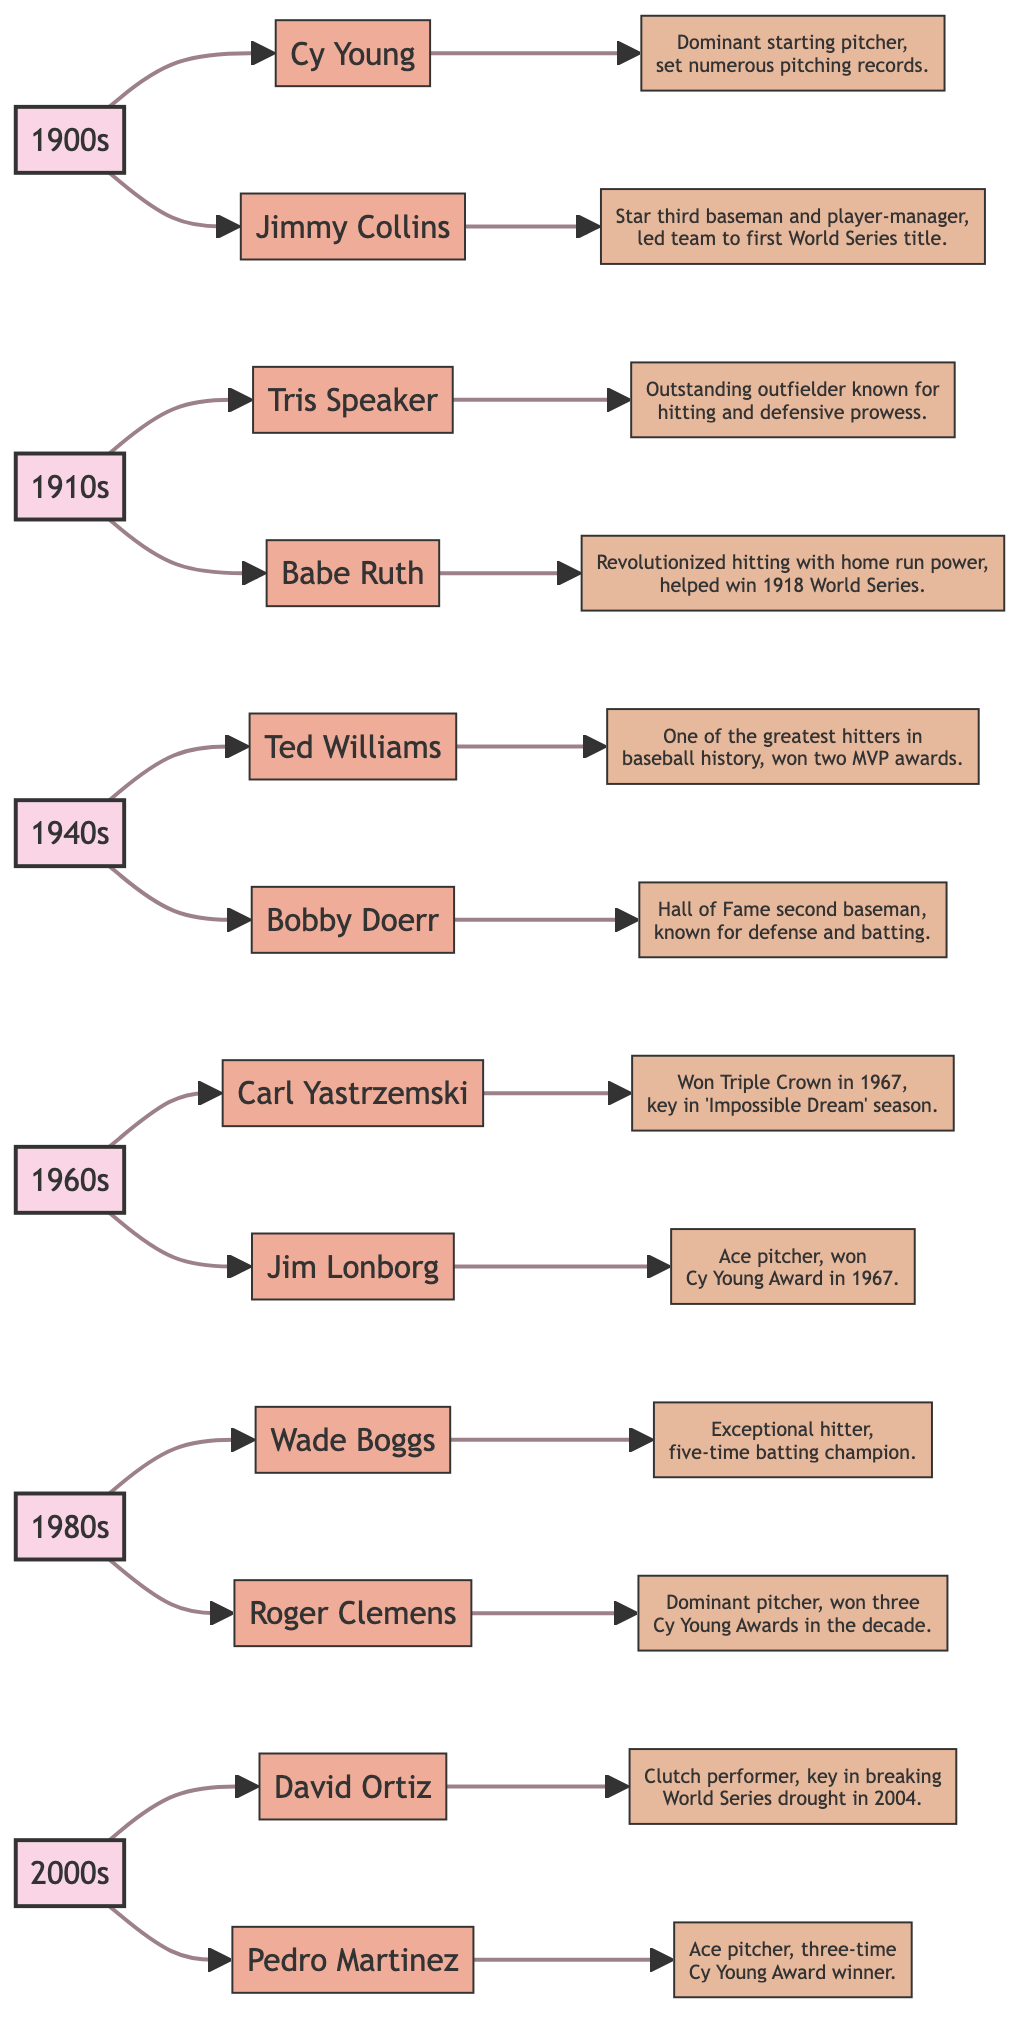What were the key contributions of Cy Young? From the diagram, Cy Young is connected to a contribution stating he was a "Dominant starting pitcher, set numerous pitching records." From the flowchart, we see the contribution directly related to his node.
Answer: Dominant starting pitcher, set numerous pitching records Which player from the 1910s helped win the World Series? The diagram shows that Babe Ruth, linked from the 1910s node, is stated to have "Revolutionized hitting with home run power, helping the team win the 1918 World Series." This indicates he played a significant role in that victory.
Answer: Babe Ruth How many Cy Young Awards did Roger Clemens win during the 1980s? According to the diagram, Roger Clemens is connected to the contribution stating he "won three Cy Young Awards during the decade." By counting this information directly from his node, we determine the result.
Answer: three Which player was noted for winning the Triple Crown in 1967? The diagram clearly shows Carl Yastrzemski being linked to the description stating he "Won the Triple Crown in 1967, key player in the 'Impossible Dream' season." Therefore, he is the one recognized for this achievement.
Answer: Carl Yastrzemski Name a player from the 1940s who won two MVP awards. According to the diagram, Ted Williams is linked to a contribution saying he is "One of the greatest hitters in baseball history, won two MVP awards." This indicates his achievement of winning MVPs in that decade.
Answer: Ted Williams Which decade includes the players David Ortiz and Pedro Martinez? The diagram shows the players David Ortiz and Pedro Martinez connected to the 2000s node. Therefore, we can directly refer back to this node to clarify the decade associated with these players.
Answer: 2000s Who is recognized as a Hall of Fame second baseman from the 1940s? The diagram presents Bobby Doerr under the 1940s node, linking him to the contribution stating he is a "Hall of Fame second baseman." Therefore, he is the recognized player for this accolade.
Answer: Bobby Doerr What pattern of contribution is shared by both players from the 1980s? Looking at the flowchart, both Wade Boggs and Roger Clemens are linked to contributions emphasizing their dominance, with Boggs noted as an "Exceptional hitter" and Clemens as a "Dominant pitcher." This pattern indicates their noteworthy performances during this decade.
Answer: Dominance in hitting and pitching 